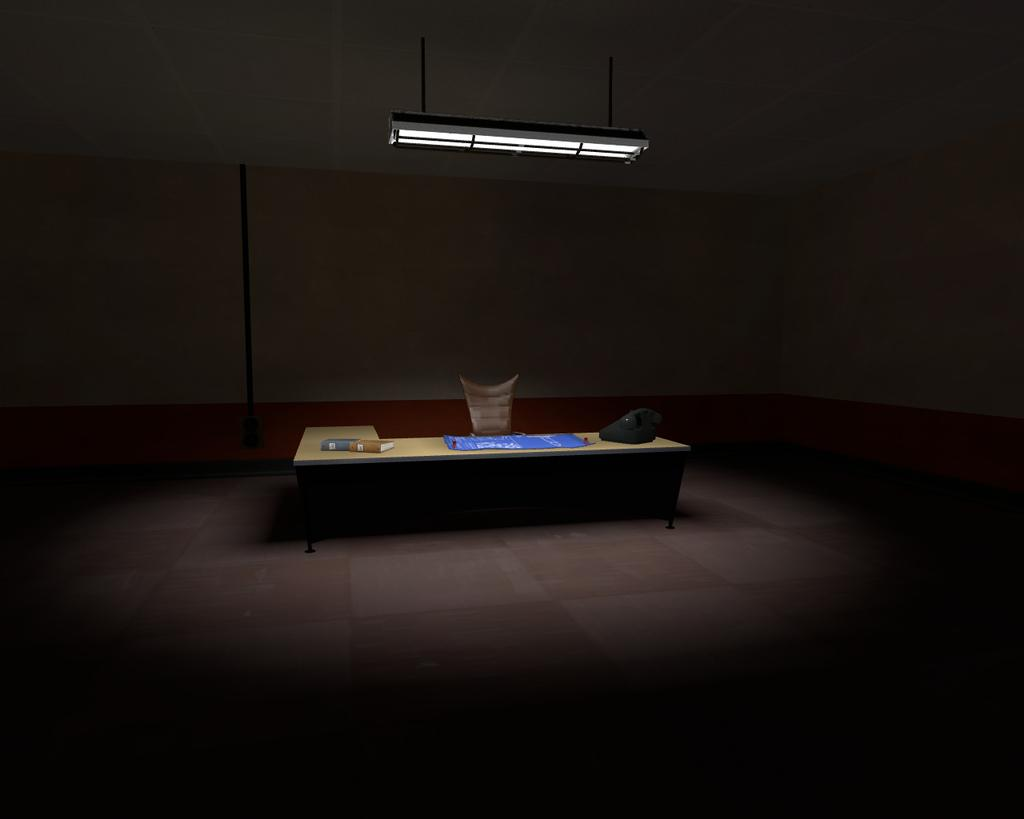What is the color of the floor in the foreground of the image? The floor in the foreground of the image is dark. What objects can be seen in the middle of the image? There is a table, a chair, a book, a telephone, and a poster in the middle of the image. What is the purpose of the pole in the middle of the image? The purpose of the pole in the middle of the image is not clear from the provided facts. What is visible at the top of the image? There is a light visible at the top of the image. How much paste is needed to cover the entire surface of the book in the image? There is no mention of paste in the image, so it is not possible to determine how much would be needed to cover the book. 